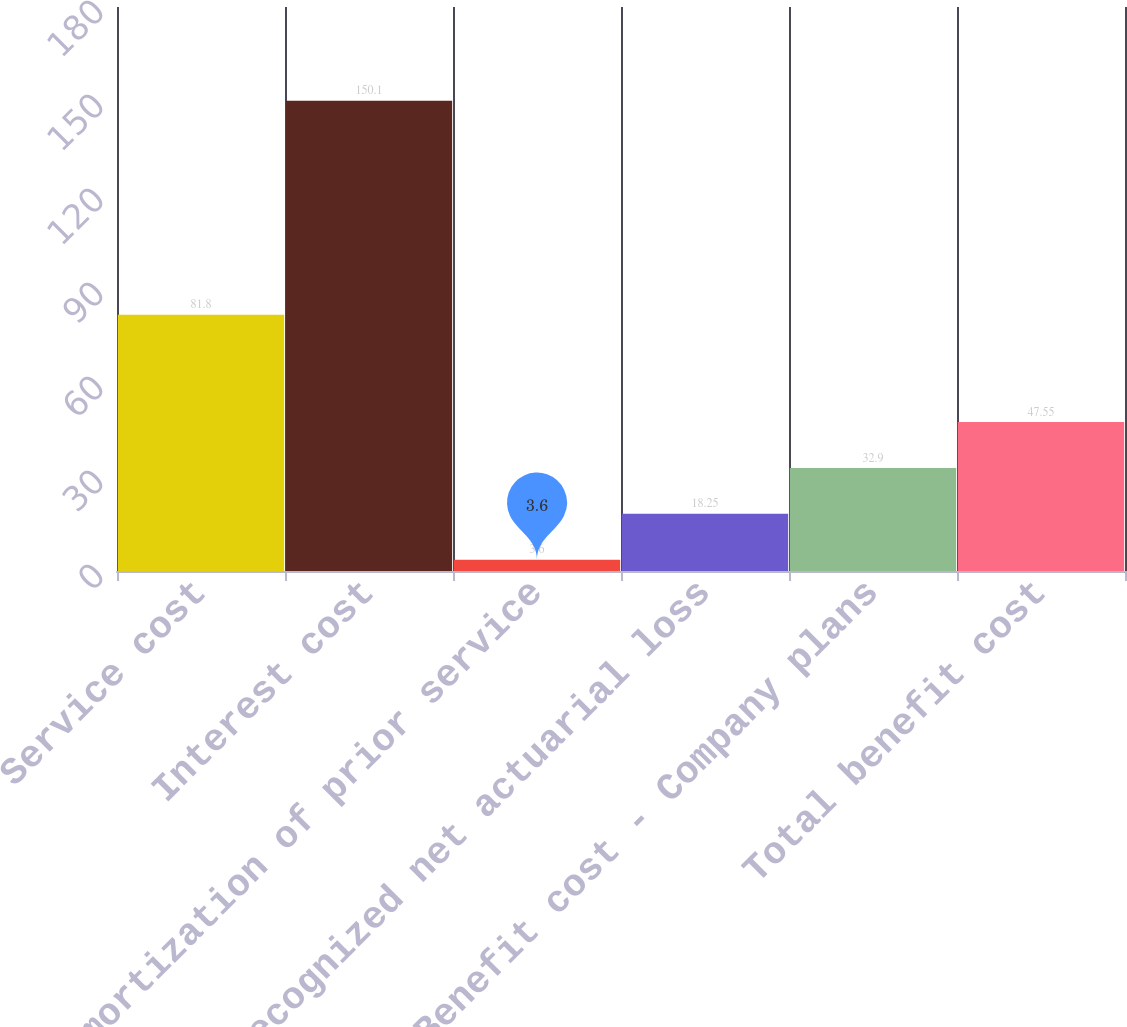Convert chart to OTSL. <chart><loc_0><loc_0><loc_500><loc_500><bar_chart><fcel>Service cost<fcel>Interest cost<fcel>Amortization of prior service<fcel>Recognized net actuarial loss<fcel>Benefit cost - Company plans<fcel>Total benefit cost<nl><fcel>81.8<fcel>150.1<fcel>3.6<fcel>18.25<fcel>32.9<fcel>47.55<nl></chart> 